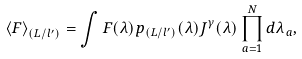<formula> <loc_0><loc_0><loc_500><loc_500>\left < F \right > _ { ( L / l ^ { \prime } ) } = \int F ( \lambda ) p _ { ( L / l ^ { \prime } ) } ( \lambda ) J ^ { \gamma } ( \lambda ) \prod _ { a = 1 } ^ { N } d \lambda _ { a } ,</formula> 